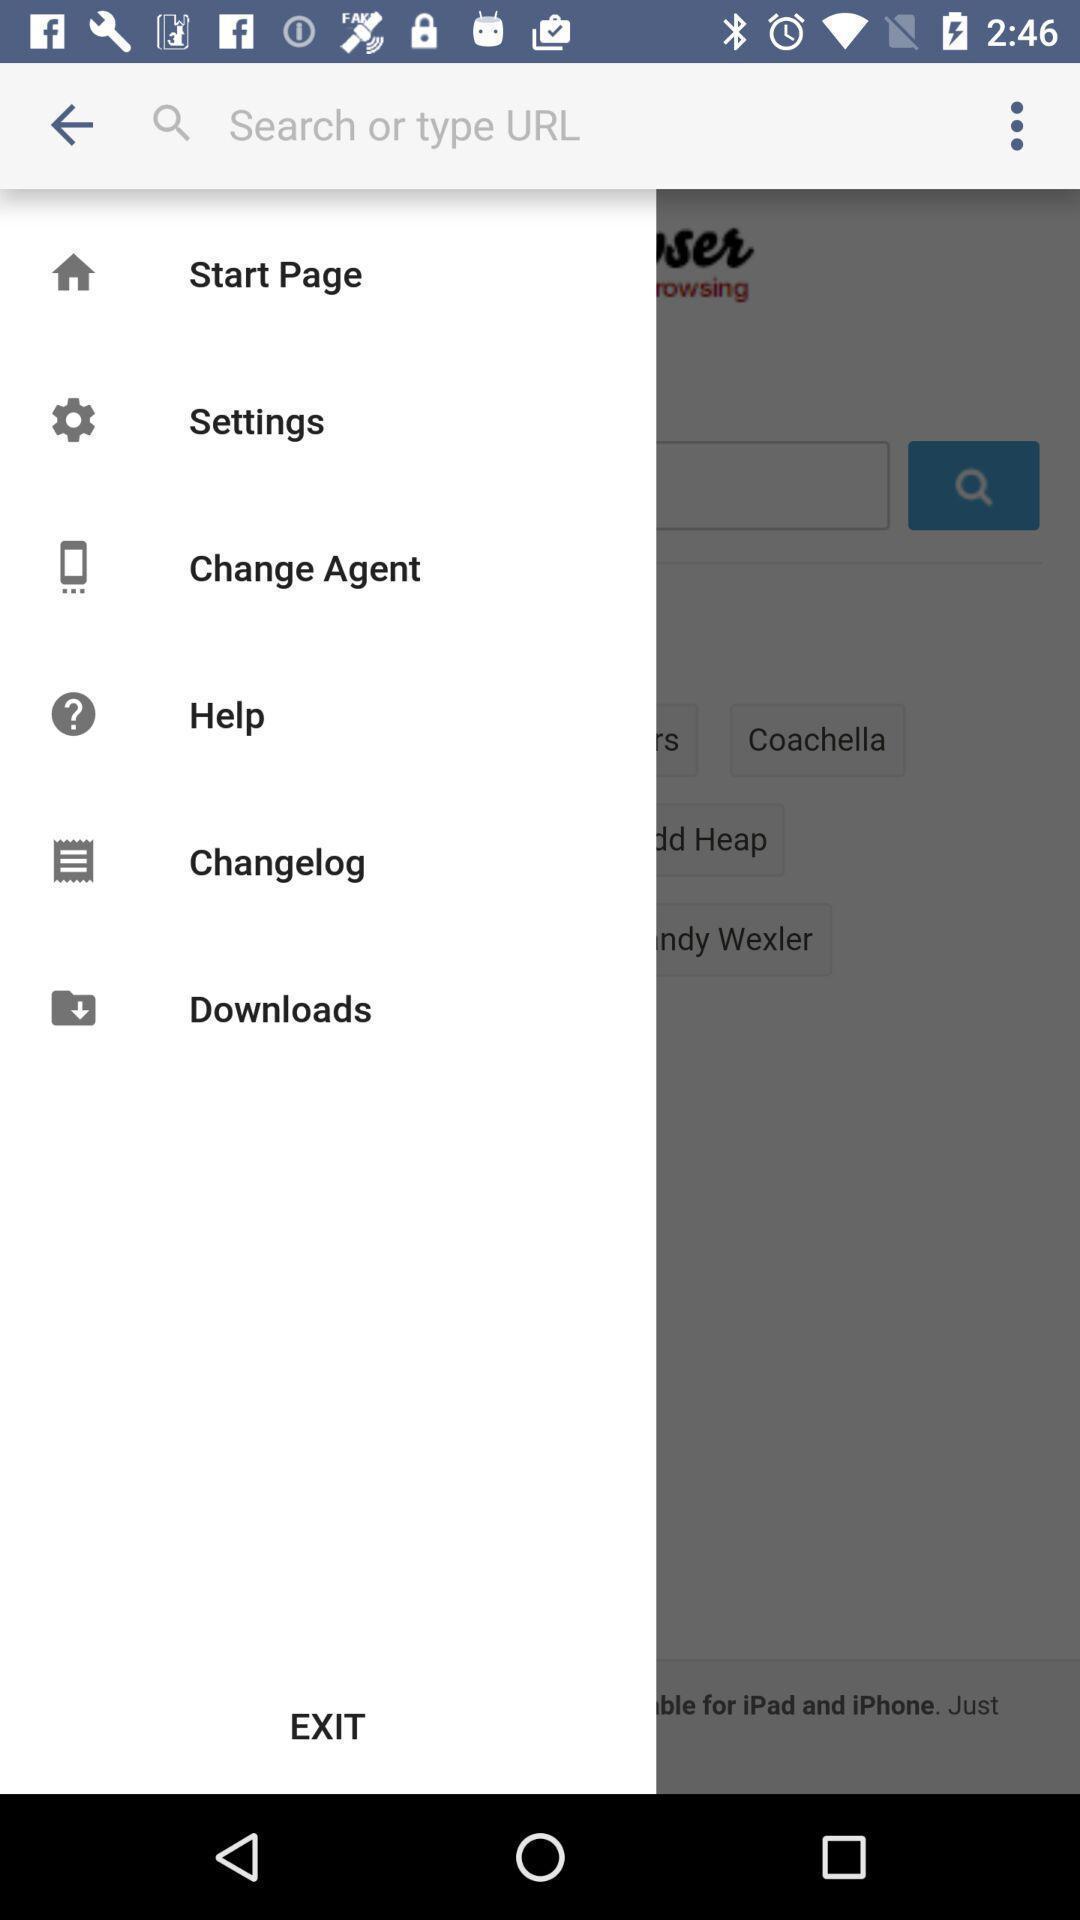Summarize the main components in this picture. Search option of the url link. 